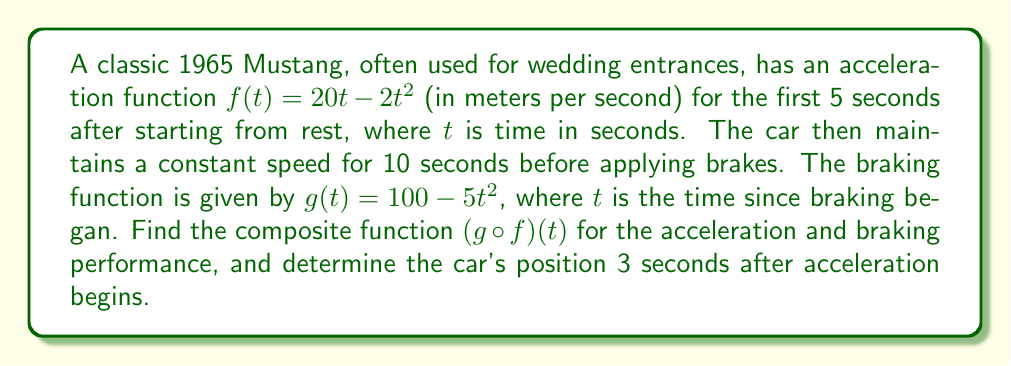Could you help me with this problem? To solve this problem, we need to follow these steps:

1) First, let's find the composite function $(g \circ f)(t)$:
   
   $f(t) = 20t - 2t^2$
   $g(t) = 100 - 5t^2$
   
   $(g \circ f)(t) = g(f(t)) = 100 - 5(f(t))^2$
   
   Substituting $f(t)$ into $g(t)$:
   
   $(g \circ f)(t) = 100 - 5(20t - 2t^2)^2$
   
   $= 100 - 5(400t^2 - 80t^3 + 4t^4)$
   
   $= 100 - 2000t^2 + 400t^3 - 20t^4$

2) Now, to find the car's position 3 seconds after acceleration begins, we need to use the original acceleration function $f(t)$, not the composite function.

3) To find the position, we need to integrate the acceleration function:

   Position = $\int f(t) dt = \int (20t - 2t^2) dt$
   
   $= 10t^2 - \frac{2}{3}t^3 + C$

4) Since the car starts from rest, the initial position is 0. We can use this to find C:

   $0 = 10(0)^2 - \frac{2}{3}(0)^3 + C$
   $C = 0$

5) Now we can find the position at $t = 3$:

   Position at $t = 3$ = $10(3)^2 - \frac{2}{3}(3)^3$
   
   $= 90 - 18 = 72$ meters
Answer: The composite function is $(g \circ f)(t) = 100 - 2000t^2 + 400t^3 - 20t^4$, and the car's position 3 seconds after acceleration begins is 72 meters. 